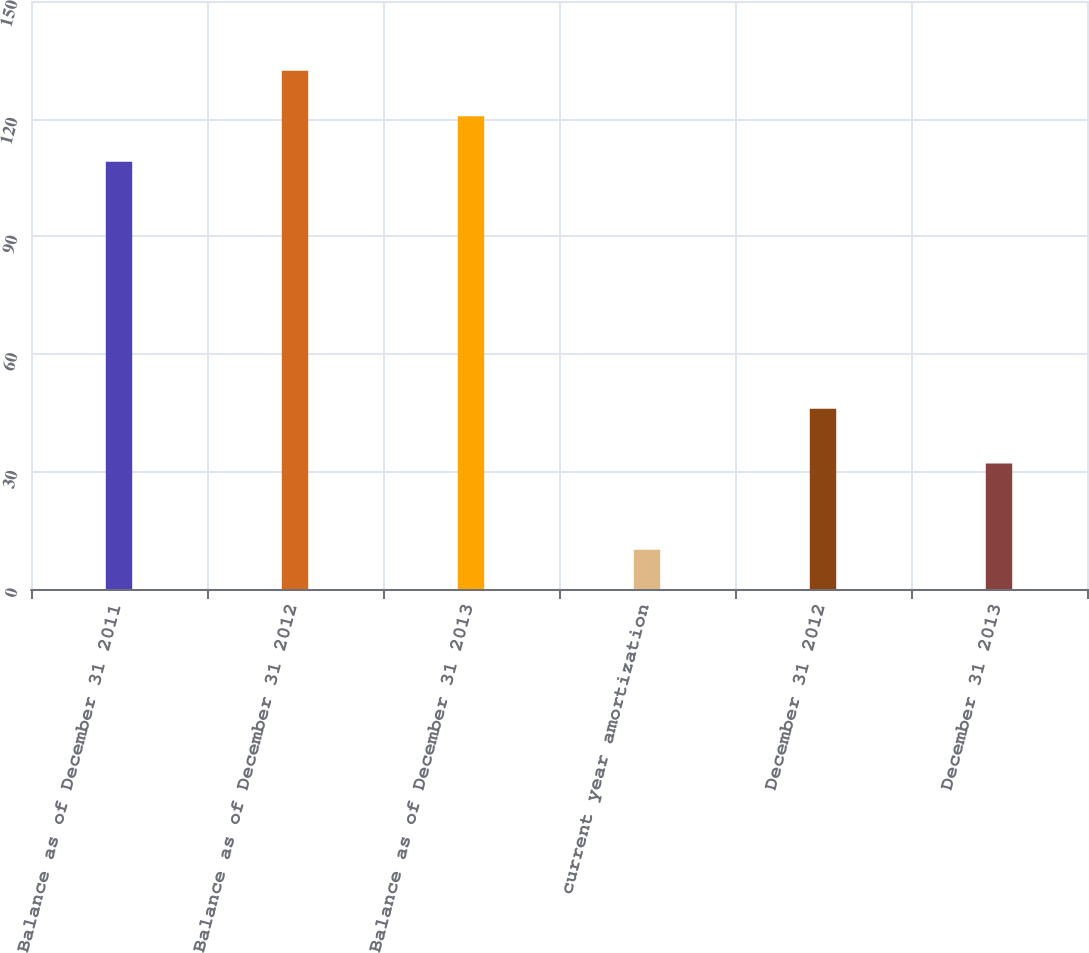Convert chart. <chart><loc_0><loc_0><loc_500><loc_500><bar_chart><fcel>Balance as of December 31 2011<fcel>Balance as of December 31 2012<fcel>Balance as of December 31 2013<fcel>current year amortization<fcel>December 31 2012<fcel>December 31 2013<nl><fcel>109<fcel>132.2<fcel>120.6<fcel>10<fcel>46<fcel>32<nl></chart> 